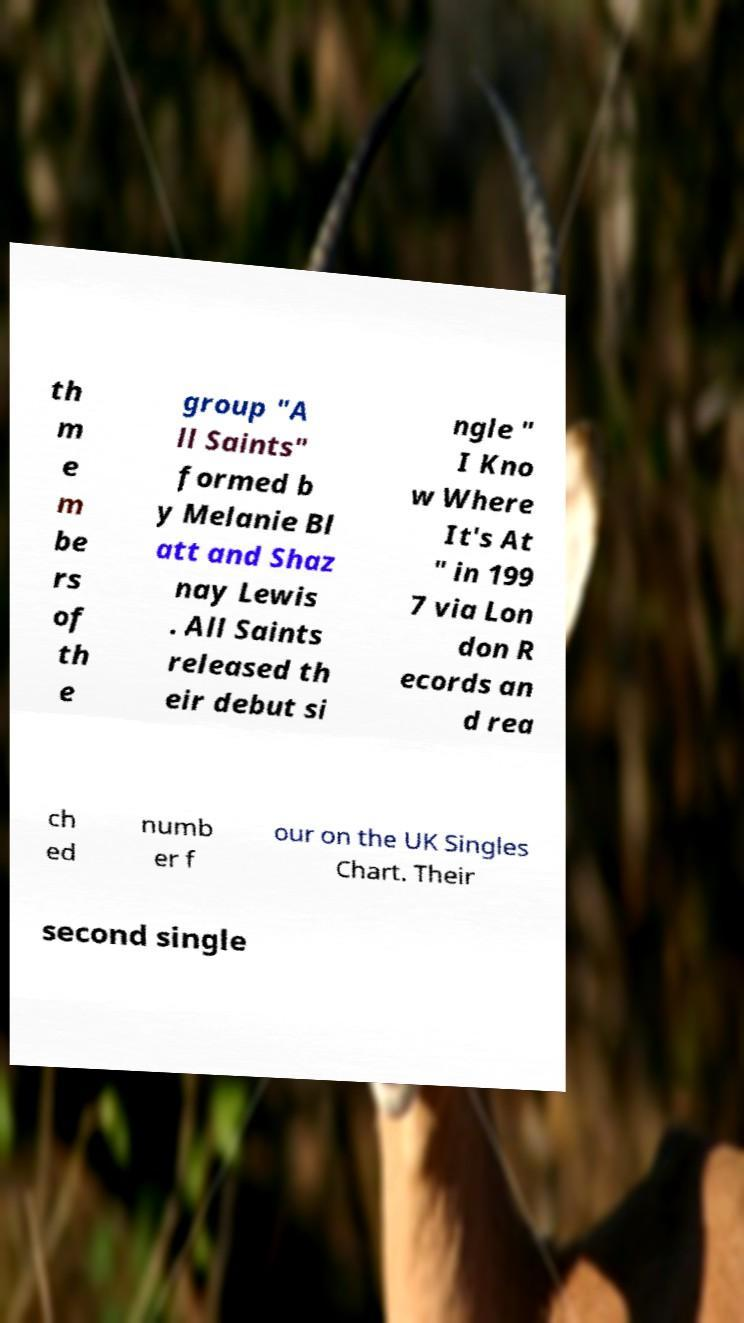Please identify and transcribe the text found in this image. th m e m be rs of th e group "A ll Saints" formed b y Melanie Bl att and Shaz nay Lewis . All Saints released th eir debut si ngle " I Kno w Where It's At " in 199 7 via Lon don R ecords an d rea ch ed numb er f our on the UK Singles Chart. Their second single 